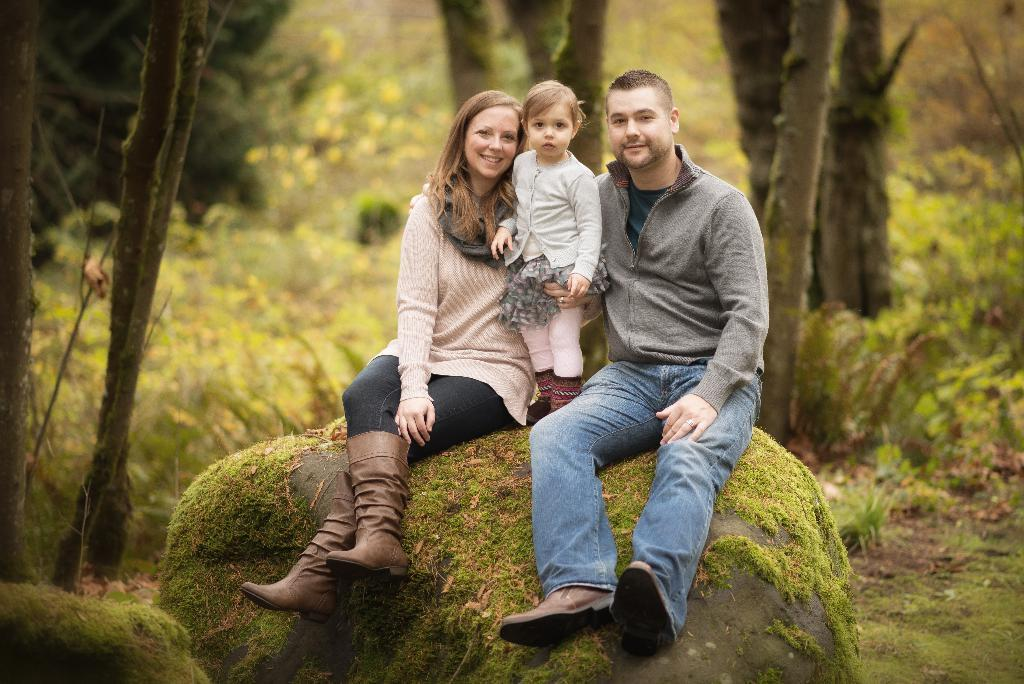How many people are in the image? There are three people in the image: a man, a woman, and a girl. What are the man and woman doing in the image? The man and woman are seated on a rock. What is the girl doing in the image? The girl is standing, and the woman is holding her. What type of vegetation is visible in the image? There are trees, grass, and plants visible in the image. How many clocks can be seen in the image? There are no clocks visible in the image. 